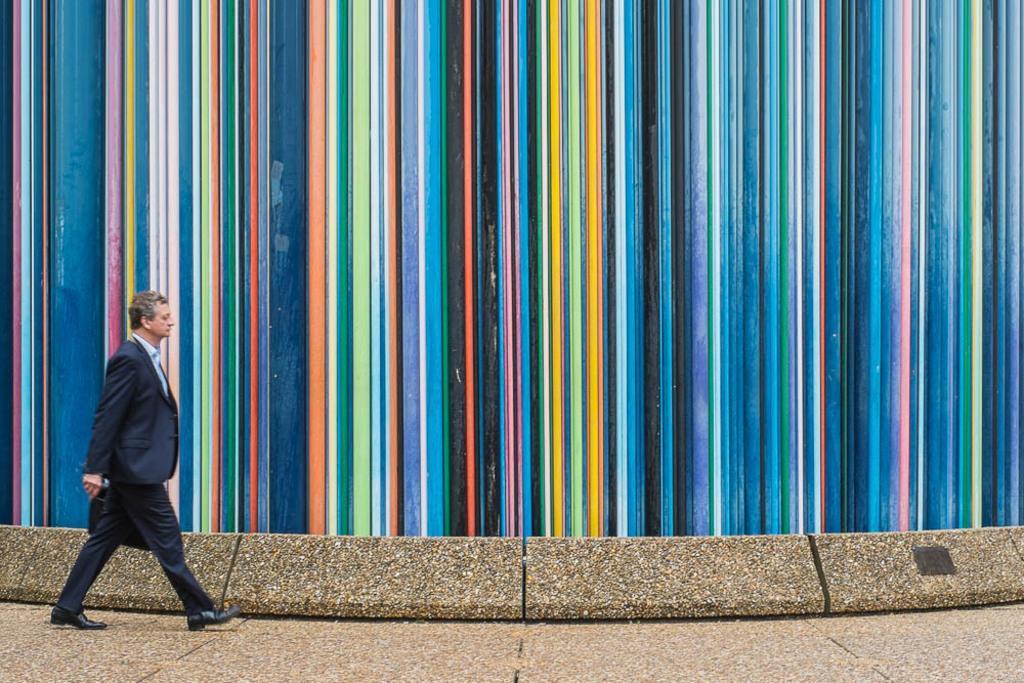Please provide a concise description of this image. In this image we can see a person walking and carrying an object. We can see a multi-colored wall. 